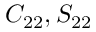Convert formula to latex. <formula><loc_0><loc_0><loc_500><loc_500>C _ { 2 2 } , S _ { 2 2 }</formula> 